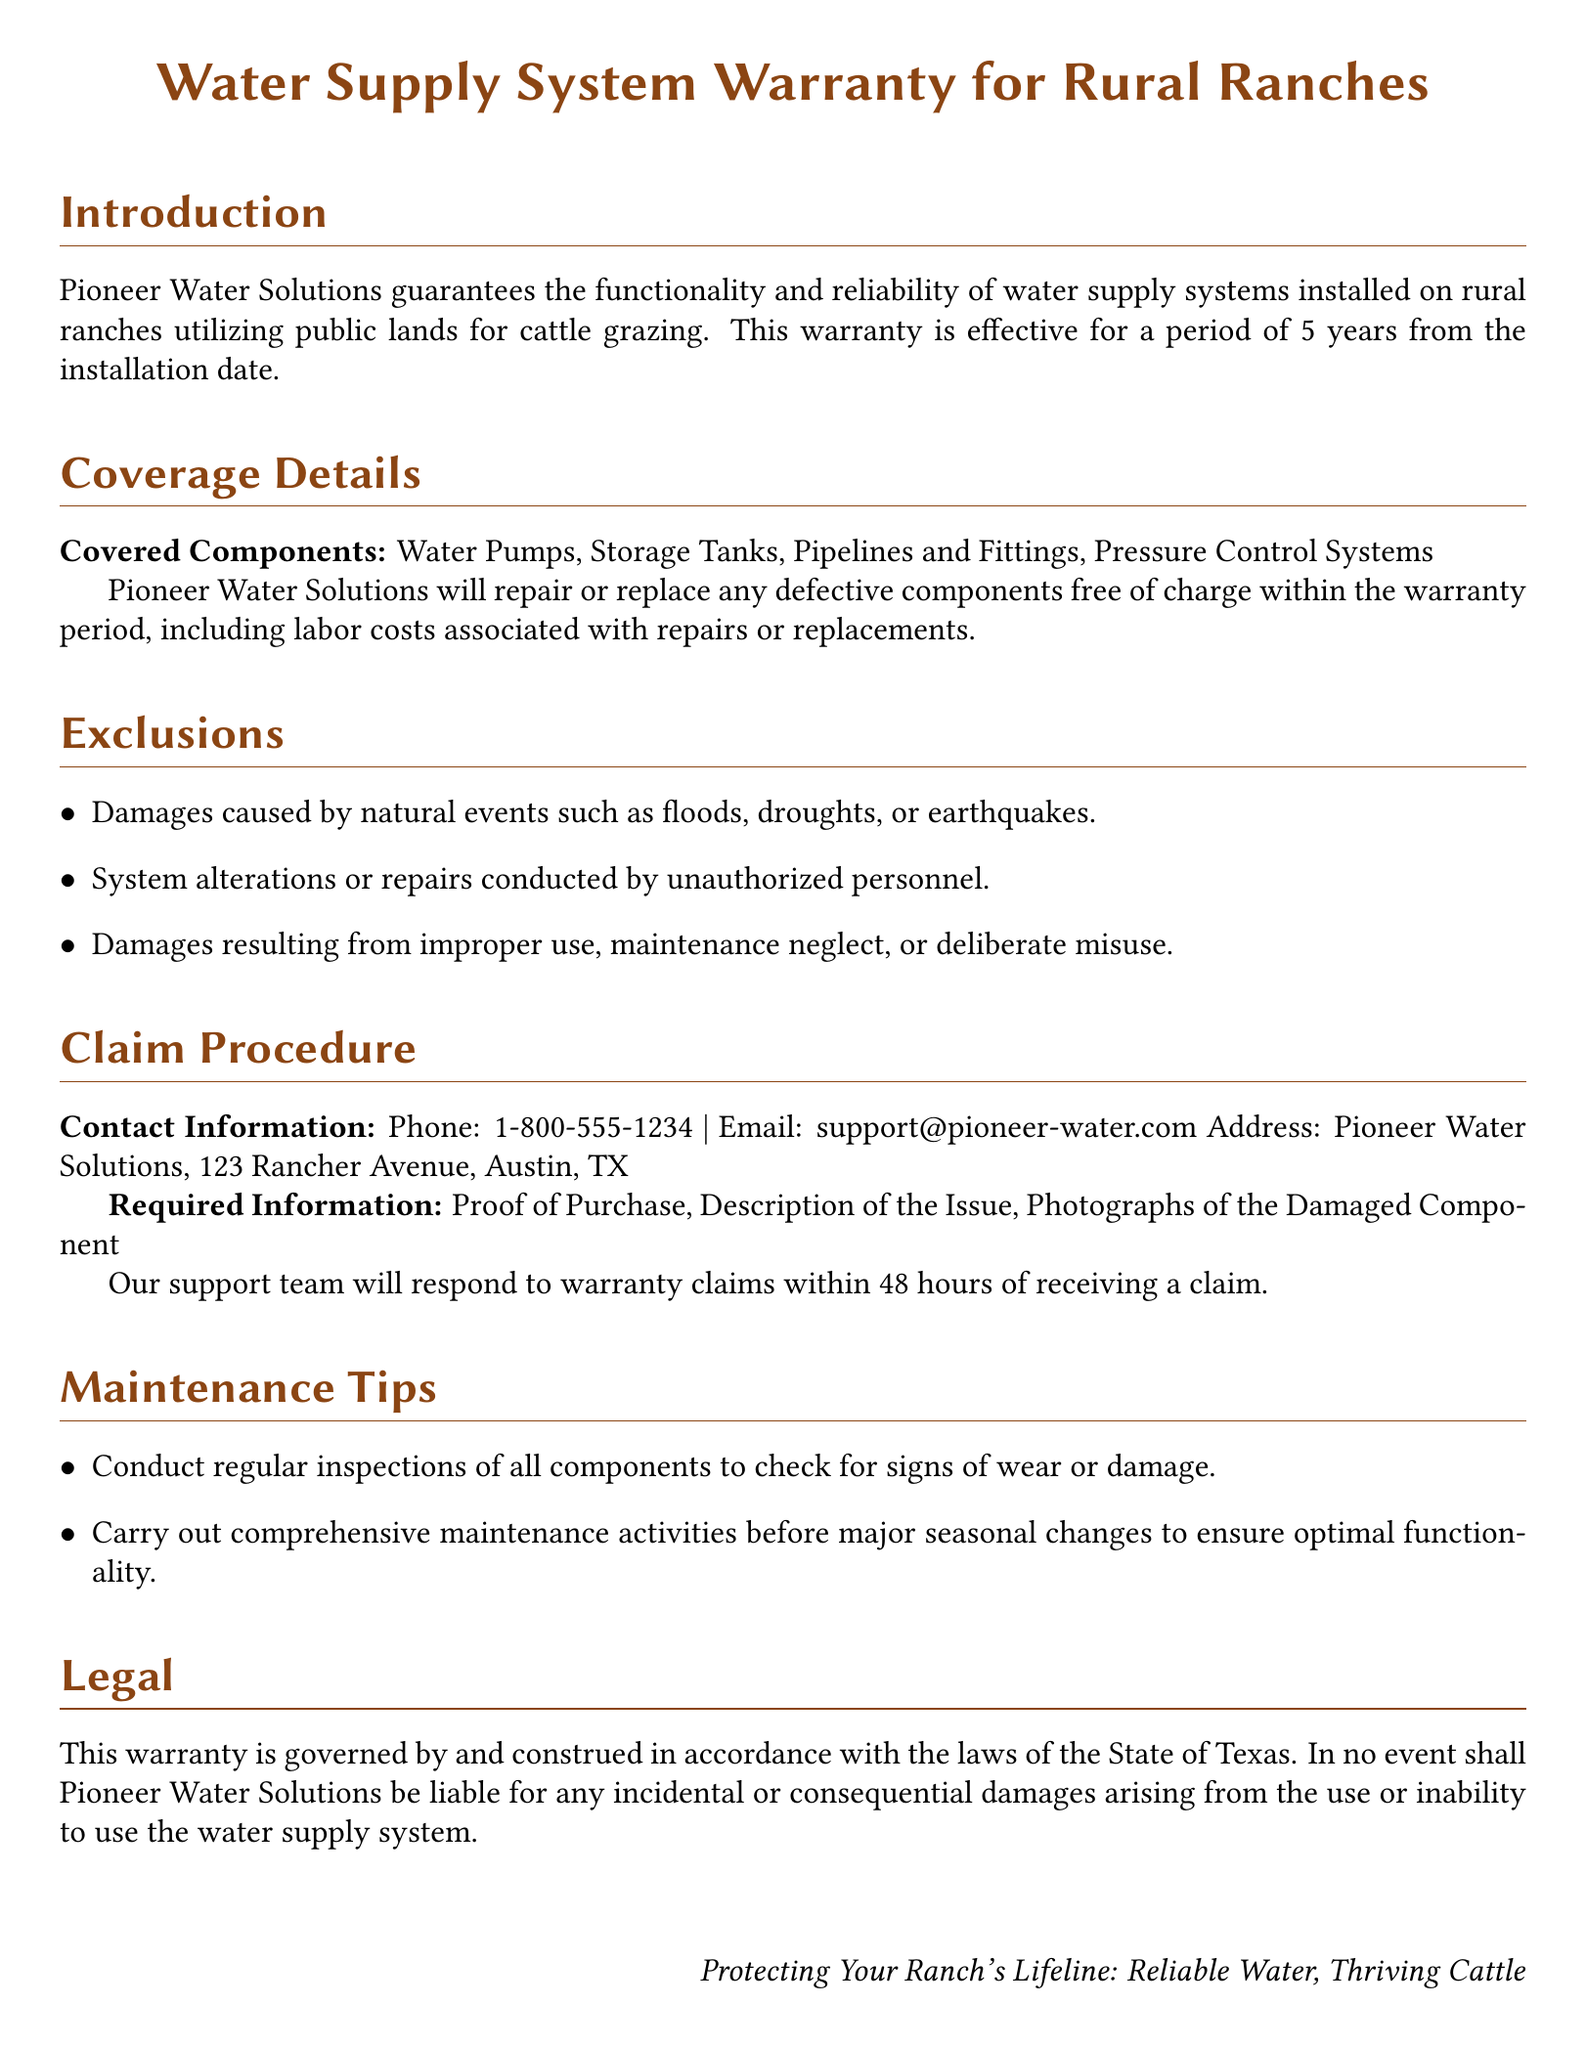What is the warranty period for the water supply system? The warranty period is effective for a period of 5 years from the installation date.
Answer: 5 years What components are covered under this warranty? The covered components include Water Pumps, Storage Tanks, Pipelines and Fittings, and Pressure Control Systems.
Answer: Water Pumps, Storage Tanks, Pipelines and Fittings, Pressure Control Systems What must be provided when making a warranty claim? Required information includes Proof of Purchase, Description of the Issue, and Photographs of the Damaged Component.
Answer: Proof of Purchase, Description of the Issue, Photographs of the Damaged Component What is the response time for warranty claims? The support team will respond to warranty claims within 48 hours of receiving a claim.
Answer: 48 hours What kind of damages are excluded from the warranty? Exclusions include damages caused by natural events, system alterations by unauthorized personnel, and damages from improper use.
Answer: Natural events, unauthorized alterations, improper use In which state is this warranty governed? This warranty is governed by and construed in accordance with the laws of the State of Texas.
Answer: Texas 